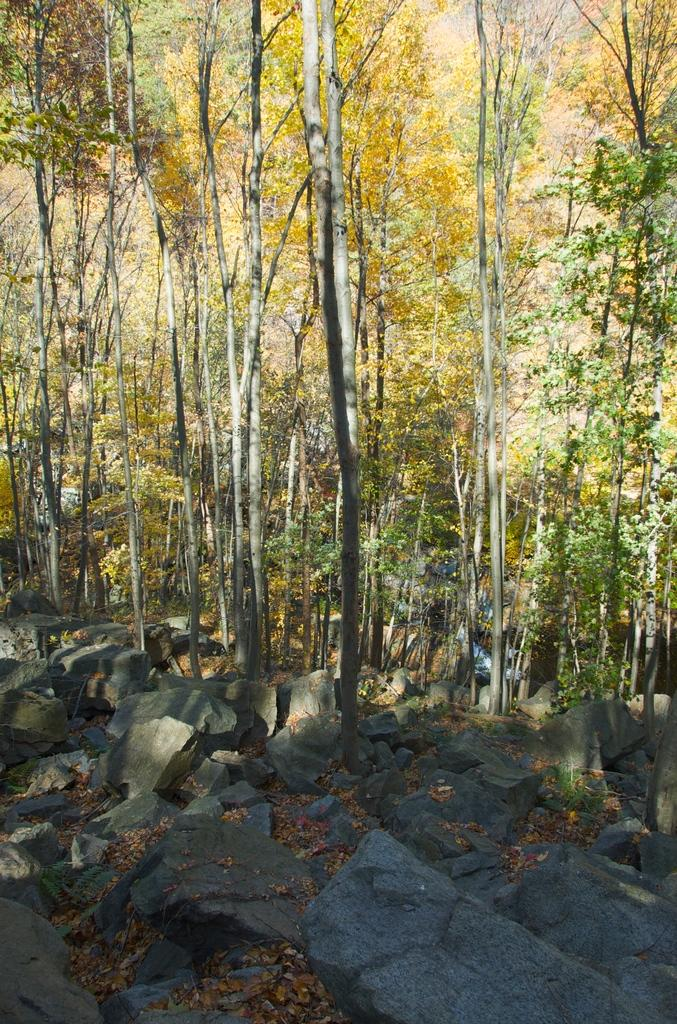What type of environment is depicted in the image? The image appears to be taken in a forest. What can be seen in the background of the image? There are many trees in the background of the image. What type of terrain is visible at the bottom of the image? There are rocks visible at the bottom of the image. What type of butter is being used to create the trail in the image? There is no butter or trail present in the image; it depicts a forest with trees and rocks. 